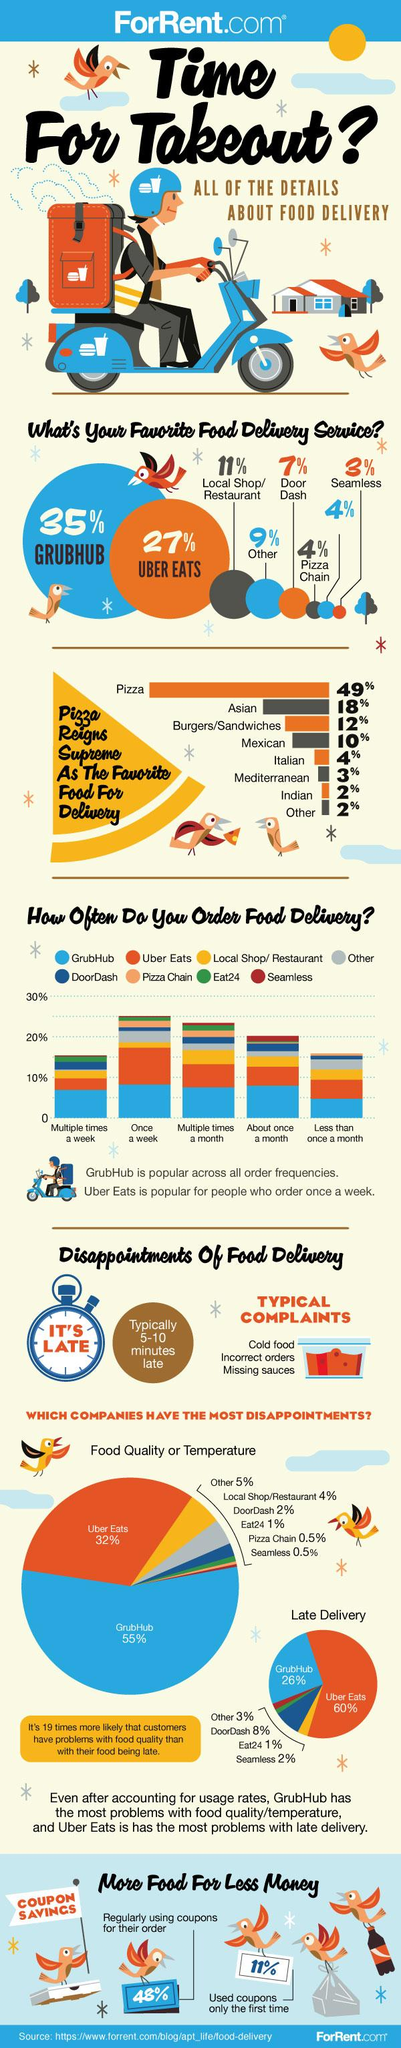Point out several critical features in this image. According to a study, only 11% of consumers use coupons for their first order and do not use them again. The frequency of ordering for Seamless is about once a month, The color of the helmet is blue, not white. According to recent data, over 60% of food delivery services in the United States are covered by Grubhub and Uber Eats. The inscription on the timer's dial reads "It's Late. 